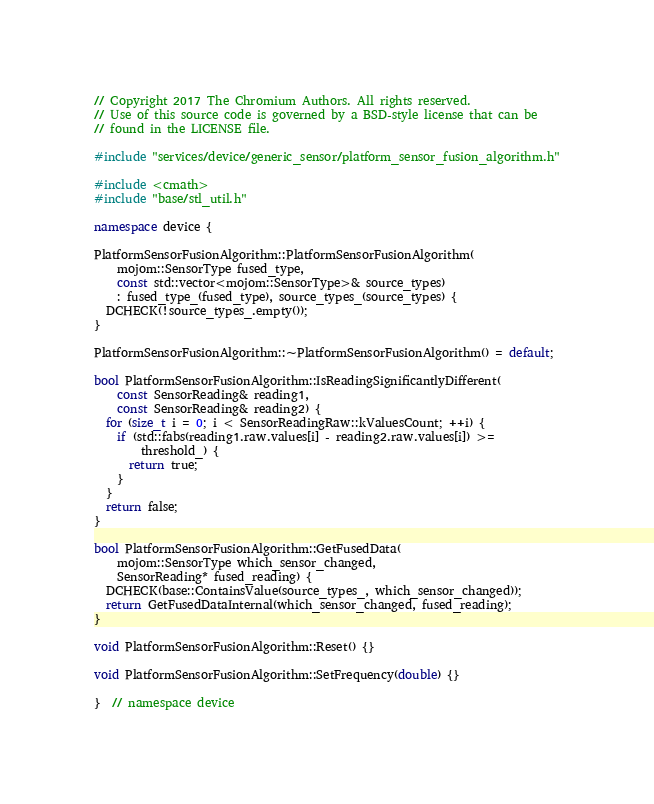Convert code to text. <code><loc_0><loc_0><loc_500><loc_500><_C++_>// Copyright 2017 The Chromium Authors. All rights reserved.
// Use of this source code is governed by a BSD-style license that can be
// found in the LICENSE file.

#include "services/device/generic_sensor/platform_sensor_fusion_algorithm.h"

#include <cmath>
#include "base/stl_util.h"

namespace device {

PlatformSensorFusionAlgorithm::PlatformSensorFusionAlgorithm(
    mojom::SensorType fused_type,
    const std::vector<mojom::SensorType>& source_types)
    : fused_type_(fused_type), source_types_(source_types) {
  DCHECK(!source_types_.empty());
}

PlatformSensorFusionAlgorithm::~PlatformSensorFusionAlgorithm() = default;

bool PlatformSensorFusionAlgorithm::IsReadingSignificantlyDifferent(
    const SensorReading& reading1,
    const SensorReading& reading2) {
  for (size_t i = 0; i < SensorReadingRaw::kValuesCount; ++i) {
    if (std::fabs(reading1.raw.values[i] - reading2.raw.values[i]) >=
        threshold_) {
      return true;
    }
  }
  return false;
}

bool PlatformSensorFusionAlgorithm::GetFusedData(
    mojom::SensorType which_sensor_changed,
    SensorReading* fused_reading) {
  DCHECK(base::ContainsValue(source_types_, which_sensor_changed));
  return GetFusedDataInternal(which_sensor_changed, fused_reading);
}

void PlatformSensorFusionAlgorithm::Reset() {}

void PlatformSensorFusionAlgorithm::SetFrequency(double) {}

}  // namespace device
</code> 